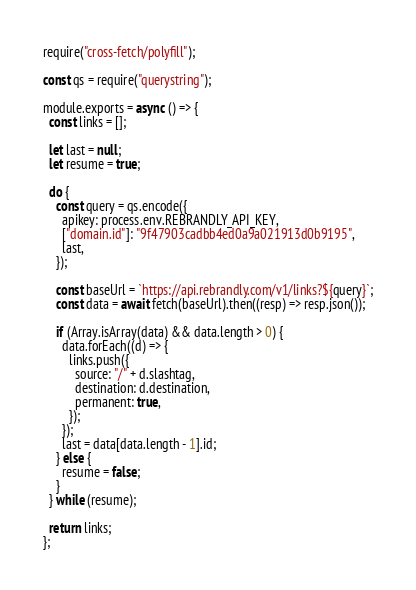<code> <loc_0><loc_0><loc_500><loc_500><_JavaScript_>require("cross-fetch/polyfill");

const qs = require("querystring");

module.exports = async () => {
  const links = [];

  let last = null;
  let resume = true;

  do {
    const query = qs.encode({
      apikey: process.env.REBRANDLY_API_KEY,
      ["domain.id"]: "9f47903cadbb4ed0a9a021913d0b9195",
      last,
    });

    const baseUrl = `https://api.rebrandly.com/v1/links?${query}`;
    const data = await fetch(baseUrl).then((resp) => resp.json());

    if (Array.isArray(data) && data.length > 0) {
      data.forEach((d) => {
        links.push({
          source: "/" + d.slashtag,
          destination: d.destination,
          permanent: true,
        });
      });
      last = data[data.length - 1].id;
    } else {
      resume = false;
    }
  } while (resume);

  return links;
};
</code> 